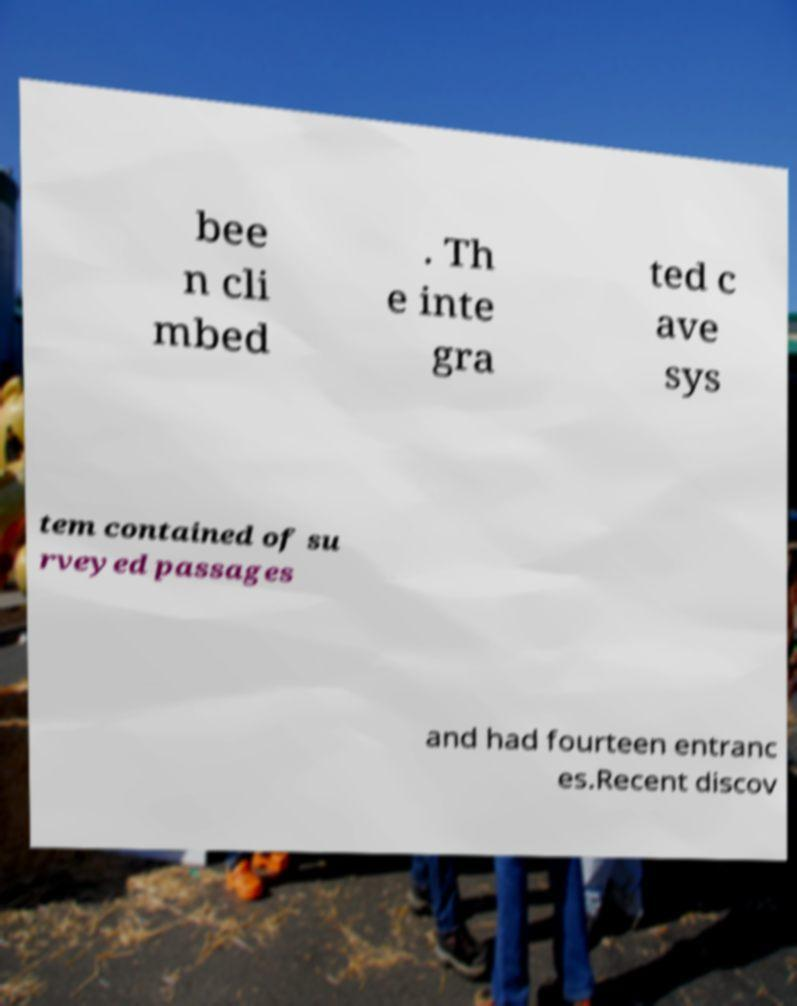For documentation purposes, I need the text within this image transcribed. Could you provide that? bee n cli mbed . Th e inte gra ted c ave sys tem contained of su rveyed passages and had fourteen entranc es.Recent discov 